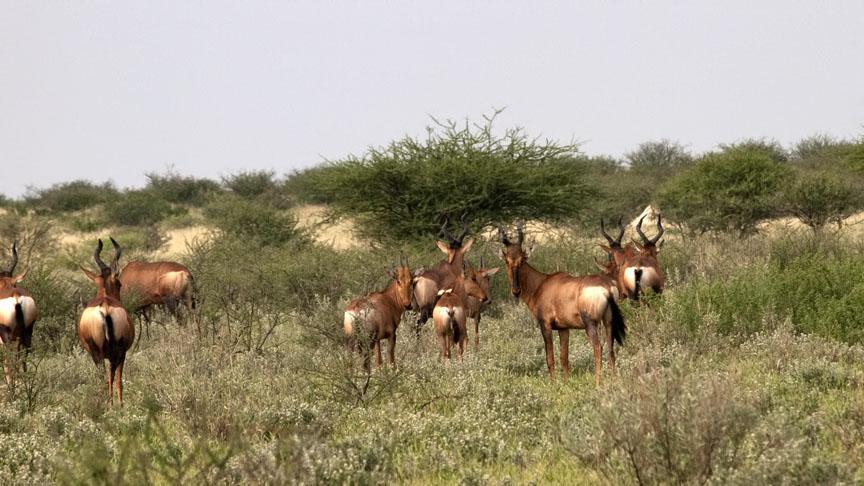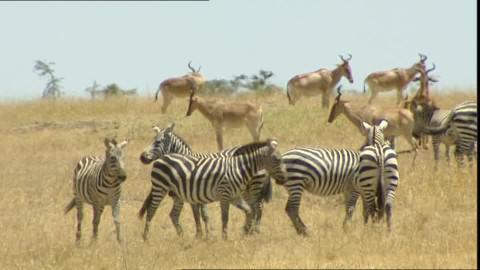The first image is the image on the left, the second image is the image on the right. Assess this claim about the two images: "There are five animals in the image on the right.". Correct or not? Answer yes or no. No. The first image is the image on the left, the second image is the image on the right. Given the left and right images, does the statement "An image shows exactly five horned animals in reclining and standing poses, with no other mammals present." hold true? Answer yes or no. No. 